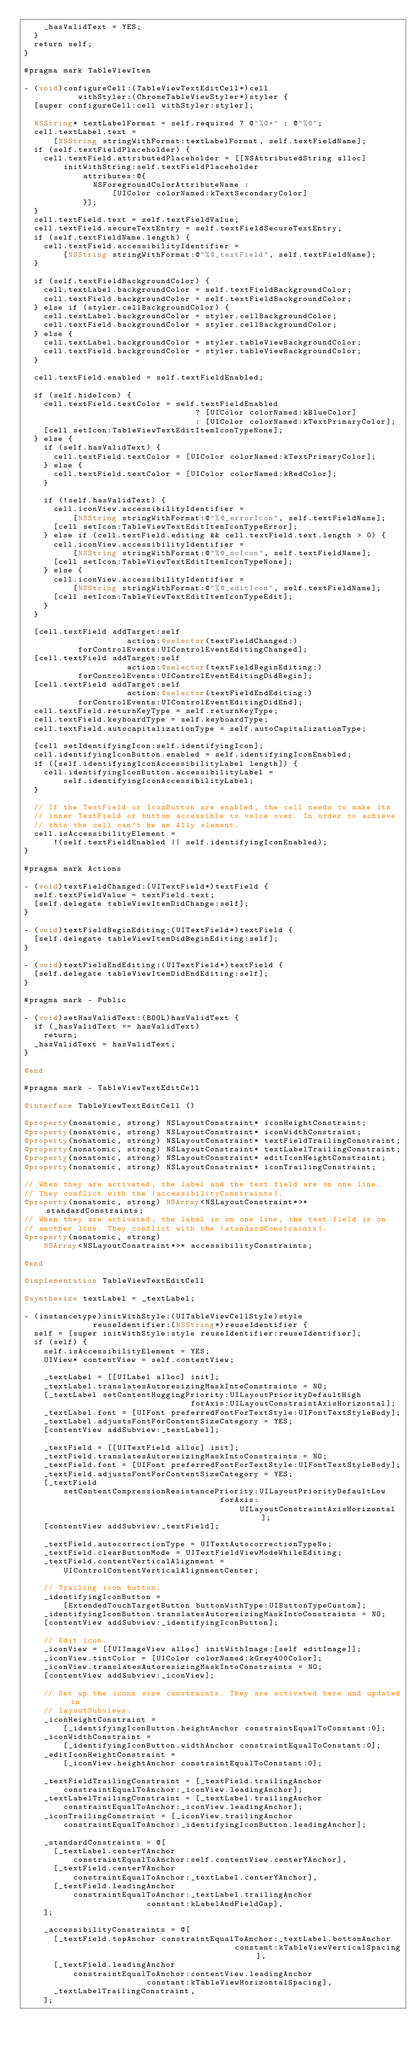<code> <loc_0><loc_0><loc_500><loc_500><_ObjectiveC_>    _hasValidText = YES;
  }
  return self;
}

#pragma mark TableViewItem

- (void)configureCell:(TableViewTextEditCell*)cell
           withStyler:(ChromeTableViewStyler*)styler {
  [super configureCell:cell withStyler:styler];

  NSString* textLabelFormat = self.required ? @"%@*" : @"%@";
  cell.textLabel.text =
      [NSString stringWithFormat:textLabelFormat, self.textFieldName];
  if (self.textFieldPlaceholder) {
    cell.textField.attributedPlaceholder = [[NSAttributedString alloc]
        initWithString:self.textFieldPlaceholder
            attributes:@{
              NSForegroundColorAttributeName :
                  [UIColor colorNamed:kTextSecondaryColor]
            }];
  }
  cell.textField.text = self.textFieldValue;
  cell.textField.secureTextEntry = self.textFieldSecureTextEntry;
  if (self.textFieldName.length) {
    cell.textField.accessibilityIdentifier =
        [NSString stringWithFormat:@"%@_textField", self.textFieldName];
  }

  if (self.textFieldBackgroundColor) {
    cell.textLabel.backgroundColor = self.textFieldBackgroundColor;
    cell.textField.backgroundColor = self.textFieldBackgroundColor;
  } else if (styler.cellBackgroundColor) {
    cell.textLabel.backgroundColor = styler.cellBackgroundColor;
    cell.textField.backgroundColor = styler.cellBackgroundColor;
  } else {
    cell.textLabel.backgroundColor = styler.tableViewBackgroundColor;
    cell.textField.backgroundColor = styler.tableViewBackgroundColor;
  }

  cell.textField.enabled = self.textFieldEnabled;

  if (self.hideIcon) {
    cell.textField.textColor = self.textFieldEnabled
                                   ? [UIColor colorNamed:kBlueColor]
                                   : [UIColor colorNamed:kTextPrimaryColor];
    [cell setIcon:TableViewTextEditItemIconTypeNone];
  } else {
    if (self.hasValidText) {
      cell.textField.textColor = [UIColor colorNamed:kTextPrimaryColor];
    } else {
      cell.textField.textColor = [UIColor colorNamed:kRedColor];
    }

    if (!self.hasValidText) {
      cell.iconView.accessibilityIdentifier =
          [NSString stringWithFormat:@"%@_errorIcon", self.textFieldName];
      [cell setIcon:TableViewTextEditItemIconTypeError];
    } else if (cell.textField.editing && cell.textField.text.length > 0) {
      cell.iconView.accessibilityIdentifier =
          [NSString stringWithFormat:@"%@_noIcon", self.textFieldName];
      [cell setIcon:TableViewTextEditItemIconTypeNone];
    } else {
      cell.iconView.accessibilityIdentifier =
          [NSString stringWithFormat:@"%@_editIcon", self.textFieldName];
      [cell setIcon:TableViewTextEditItemIconTypeEdit];
    }
  }

  [cell.textField addTarget:self
                     action:@selector(textFieldChanged:)
           forControlEvents:UIControlEventEditingChanged];
  [cell.textField addTarget:self
                     action:@selector(textFieldBeginEditing:)
           forControlEvents:UIControlEventEditingDidBegin];
  [cell.textField addTarget:self
                     action:@selector(textFieldEndEditing:)
           forControlEvents:UIControlEventEditingDidEnd];
  cell.textField.returnKeyType = self.returnKeyType;
  cell.textField.keyboardType = self.keyboardType;
  cell.textField.autocapitalizationType = self.autoCapitalizationType;

  [cell setIdentifyingIcon:self.identifyingIcon];
  cell.identifyingIconButton.enabled = self.identifyingIconEnabled;
  if ([self.identifyingIconAccessibilityLabel length]) {
    cell.identifyingIconButton.accessibilityLabel =
        self.identifyingIconAccessibilityLabel;
  }

  // If the TextField or IconButton are enabled, the cell needs to make its
  // inner TextField or button accessible to voice over. In order to achieve
  // this the cell can't be an A11y element.
  cell.isAccessibilityElement =
      !(self.textFieldEnabled || self.identifyingIconEnabled);
}

#pragma mark Actions

- (void)textFieldChanged:(UITextField*)textField {
  self.textFieldValue = textField.text;
  [self.delegate tableViewItemDidChange:self];
}

- (void)textFieldBeginEditing:(UITextField*)textField {
  [self.delegate tableViewItemDidBeginEditing:self];
}

- (void)textFieldEndEditing:(UITextField*)textField {
  [self.delegate tableViewItemDidEndEditing:self];
}

#pragma mark - Public

- (void)setHasValidText:(BOOL)hasValidText {
  if (_hasValidText == hasValidText)
    return;
  _hasValidText = hasValidText;
}

@end

#pragma mark - TableViewTextEditCell

@interface TableViewTextEditCell ()

@property(nonatomic, strong) NSLayoutConstraint* iconHeightConstraint;
@property(nonatomic, strong) NSLayoutConstraint* iconWidthConstraint;
@property(nonatomic, strong) NSLayoutConstraint* textFieldTrailingConstraint;
@property(nonatomic, strong) NSLayoutConstraint* textLabelTrailingConstraint;
@property(nonatomic, strong) NSLayoutConstraint* editIconHeightConstraint;
@property(nonatomic, strong) NSLayoutConstraint* iconTrailingConstraint;

// When they are activated, the label and the text field are on one line.
// They conflict with the |accessibilityConstraints|.
@property(nonatomic, strong) NSArray<NSLayoutConstraint*>* standardConstraints;
// When they are activated, the label is on one line, the text field is on
// another line. They conflict with the |standardConstraints|.
@property(nonatomic, strong)
    NSArray<NSLayoutConstraint*>* accessibilityConstraints;

@end

@implementation TableViewTextEditCell

@synthesize textLabel = _textLabel;

- (instancetype)initWithStyle:(UITableViewCellStyle)style
              reuseIdentifier:(NSString*)reuseIdentifier {
  self = [super initWithStyle:style reuseIdentifier:reuseIdentifier];
  if (self) {
    self.isAccessibilityElement = YES;
    UIView* contentView = self.contentView;

    _textLabel = [[UILabel alloc] init];
    _textLabel.translatesAutoresizingMaskIntoConstraints = NO;
    [_textLabel setContentHuggingPriority:UILayoutPriorityDefaultHigh
                                  forAxis:UILayoutConstraintAxisHorizontal];
    _textLabel.font = [UIFont preferredFontForTextStyle:UIFontTextStyleBody];
    _textLabel.adjustsFontForContentSizeCategory = YES;
    [contentView addSubview:_textLabel];

    _textField = [[UITextField alloc] init];
    _textField.translatesAutoresizingMaskIntoConstraints = NO;
    _textField.font = [UIFont preferredFontForTextStyle:UIFontTextStyleBody];
    _textField.adjustsFontForContentSizeCategory = YES;
    [_textField
        setContentCompressionResistancePriority:UILayoutPriorityDefaultLow
                                        forAxis:
                                            UILayoutConstraintAxisHorizontal];
    [contentView addSubview:_textField];

    _textField.autocorrectionType = UITextAutocorrectionTypeNo;
    _textField.clearButtonMode = UITextFieldViewModeWhileEditing;
    _textField.contentVerticalAlignment =
        UIControlContentVerticalAlignmentCenter;

    // Trailing icon button.
    _identifyingIconButton =
        [ExtendedTouchTargetButton buttonWithType:UIButtonTypeCustom];
    _identifyingIconButton.translatesAutoresizingMaskIntoConstraints = NO;
    [contentView addSubview:_identifyingIconButton];

    // Edit icon.
    _iconView = [[UIImageView alloc] initWithImage:[self editImage]];
    _iconView.tintColor = [UIColor colorNamed:kGrey400Color];
    _iconView.translatesAutoresizingMaskIntoConstraints = NO;
    [contentView addSubview:_iconView];

    // Set up the icons size constraints. They are activated here and updated in
    // layoutSubviews.
    _iconHeightConstraint =
        [_identifyingIconButton.heightAnchor constraintEqualToConstant:0];
    _iconWidthConstraint =
        [_identifyingIconButton.widthAnchor constraintEqualToConstant:0];
    _editIconHeightConstraint =
        [_iconView.heightAnchor constraintEqualToConstant:0];

    _textFieldTrailingConstraint = [_textField.trailingAnchor
        constraintEqualToAnchor:_iconView.leadingAnchor];
    _textLabelTrailingConstraint = [_textLabel.trailingAnchor
        constraintEqualToAnchor:_iconView.leadingAnchor];
    _iconTrailingConstraint = [_iconView.trailingAnchor
        constraintEqualToAnchor:_identifyingIconButton.leadingAnchor];

    _standardConstraints = @[
      [_textLabel.centerYAnchor
          constraintEqualToAnchor:self.contentView.centerYAnchor],
      [_textField.centerYAnchor
          constraintEqualToAnchor:_textLabel.centerYAnchor],
      [_textField.leadingAnchor
          constraintEqualToAnchor:_textLabel.trailingAnchor
                         constant:kLabelAndFieldGap],
    ];

    _accessibilityConstraints = @[
      [_textField.topAnchor constraintEqualToAnchor:_textLabel.bottomAnchor
                                           constant:kTableViewVerticalSpacing],
      [_textField.leadingAnchor
          constraintEqualToAnchor:contentView.leadingAnchor
                         constant:kTableViewHorizontalSpacing],
      _textLabelTrailingConstraint,
    ];
</code> 